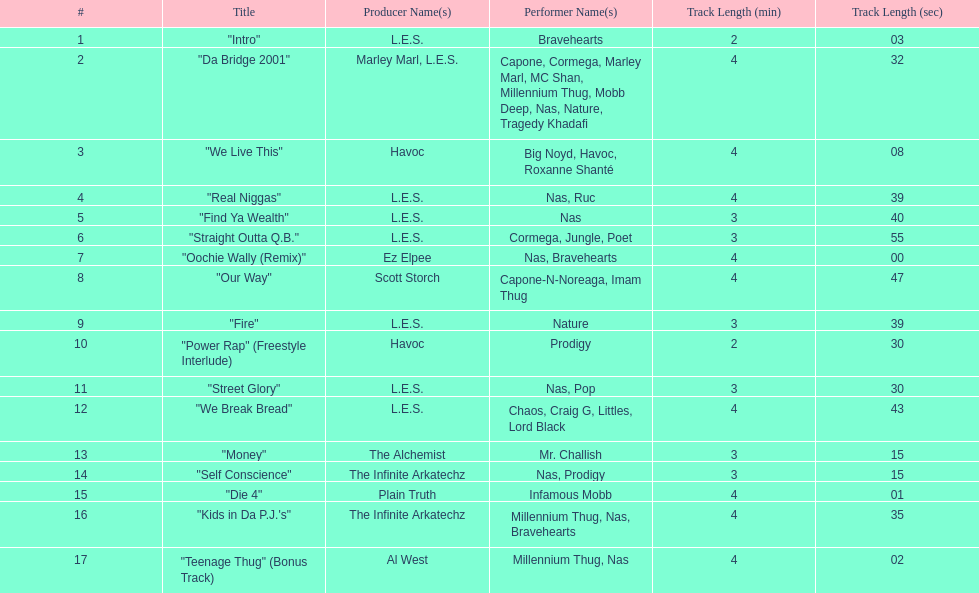How long os the longest track on the album? 4:47. 